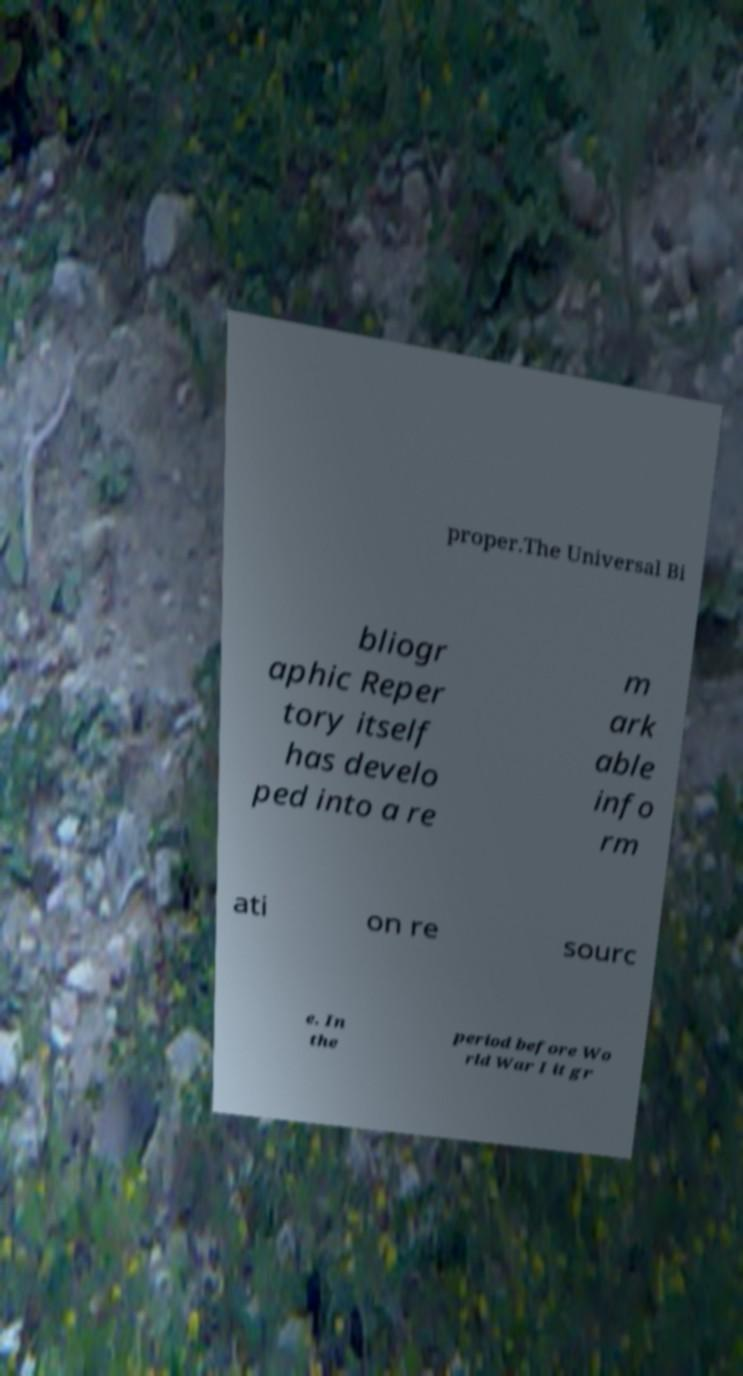Can you accurately transcribe the text from the provided image for me? proper.The Universal Bi bliogr aphic Reper tory itself has develo ped into a re m ark able info rm ati on re sourc e. In the period before Wo rld War I it gr 